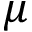Convert formula to latex. <formula><loc_0><loc_0><loc_500><loc_500>\mu</formula> 